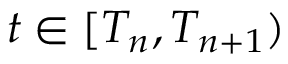Convert formula to latex. <formula><loc_0><loc_0><loc_500><loc_500>t \in [ T _ { n } , T _ { n + 1 } )</formula> 